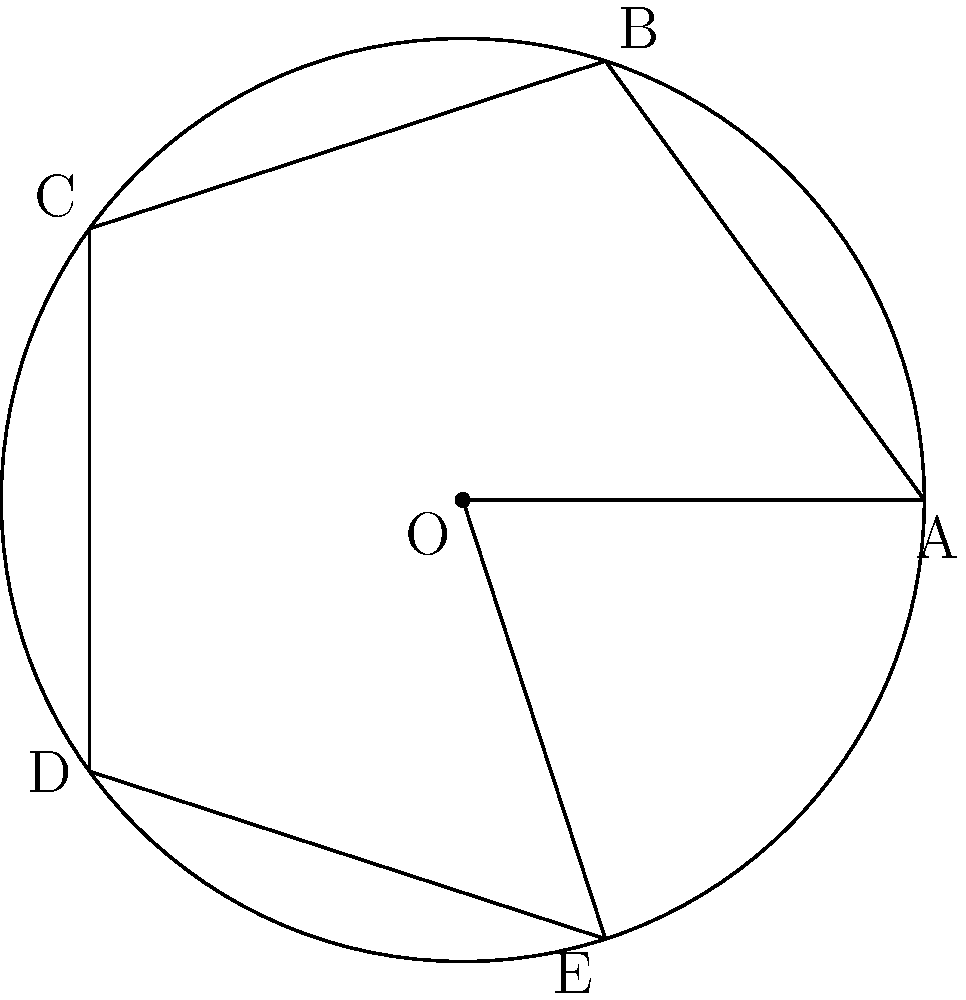En muchas culturas, los símbolos geométricos tienen un significado especial. Consideremos un símbolo cultural en forma de estrella de cinco puntas inscrita en un círculo. Si rotamos este símbolo alrededor de su centro O en sentido horario, ¿cuántos grados debemos girar para que el símbolo vuelva a su posición original, creando así un patrón simétrico? Para resolver esta pregunta, seguiremos estos pasos:

1) Observemos que la estrella de cinco puntas está inscrita en un círculo y tiene 5 puntos equidistantes (A, B, C, D, E).

2) En una rotación completa (360°), el símbolo debe volver a su posición original.

3) Debido a la simetría del símbolo, también volverá a su posición original después de rotaciones más pequeñas.

4) El ángulo entre dos puntas consecutivas de la estrella es:
   $$\frac{360°}{5} = 72°$$

5) Esto significa que cada vez que rotamos 72°, el símbolo parece idéntico a su posición original.

6) Por lo tanto, las rotaciones que hacen que el símbolo vuelva a su posición original son múltiplos de 72°:
   72°, 144°, 216°, 288°, 360°

7) La rotación más pequeña que hace que el símbolo vuelva a su posición original es 72°.

Este concepto de simetría rotacional es común en muchos símbolos culturales y puede reflejar ideas de ciclos, renovación o unidad en diversas tradiciones.
Answer: 72° 